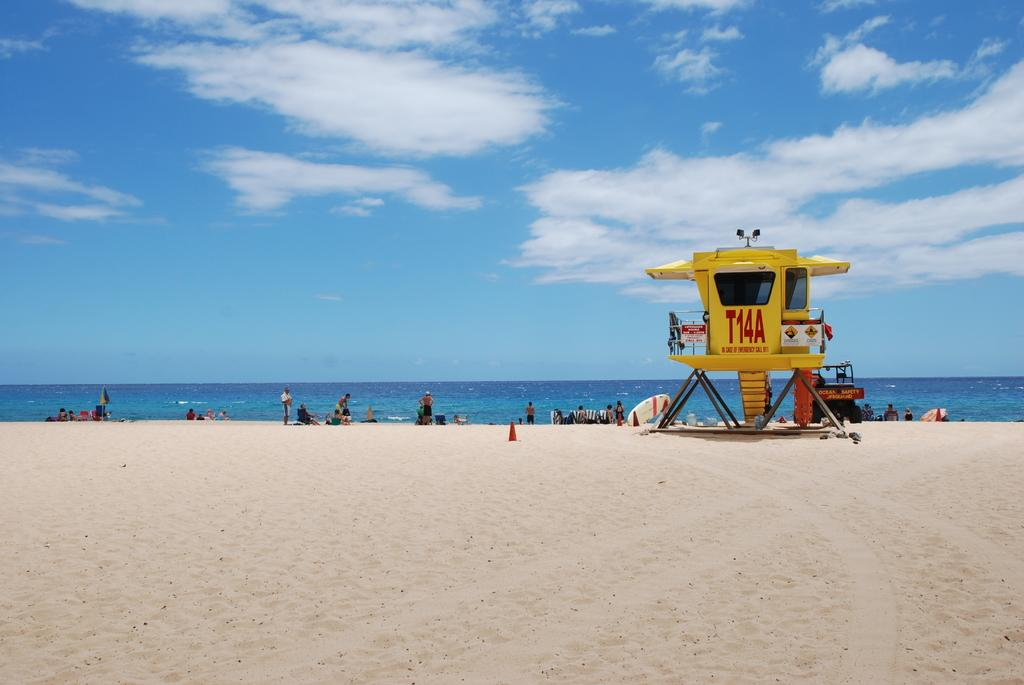Provide a one-sentence caption for the provided image. People at a beach on a nice day are being watched over by a lifeguard at station T14A. 